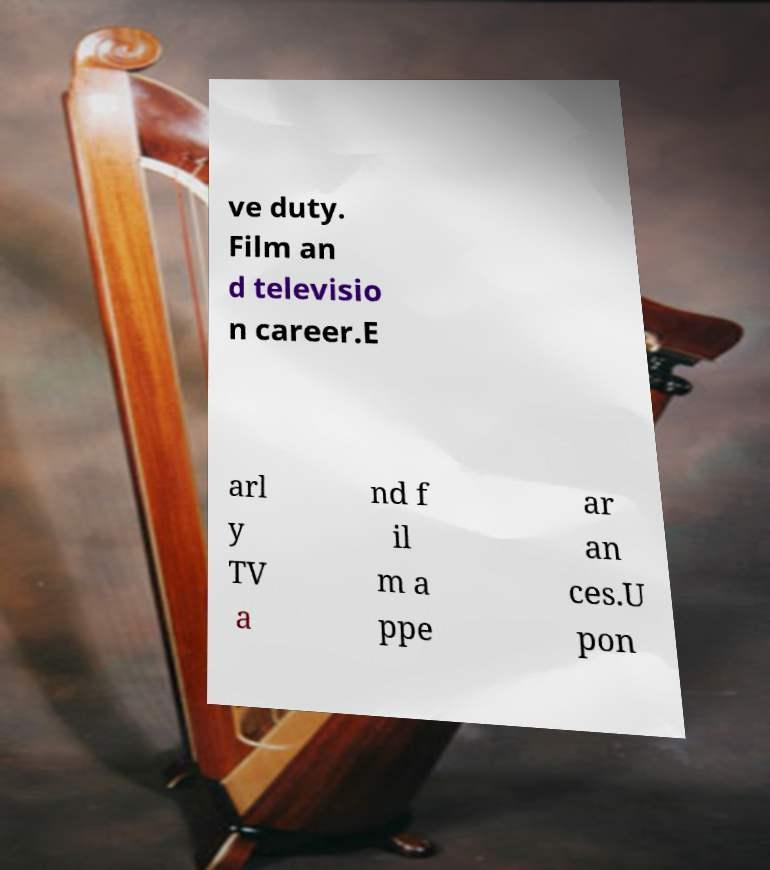Can you read and provide the text displayed in the image?This photo seems to have some interesting text. Can you extract and type it out for me? ve duty. Film an d televisio n career.E arl y TV a nd f il m a ppe ar an ces.U pon 